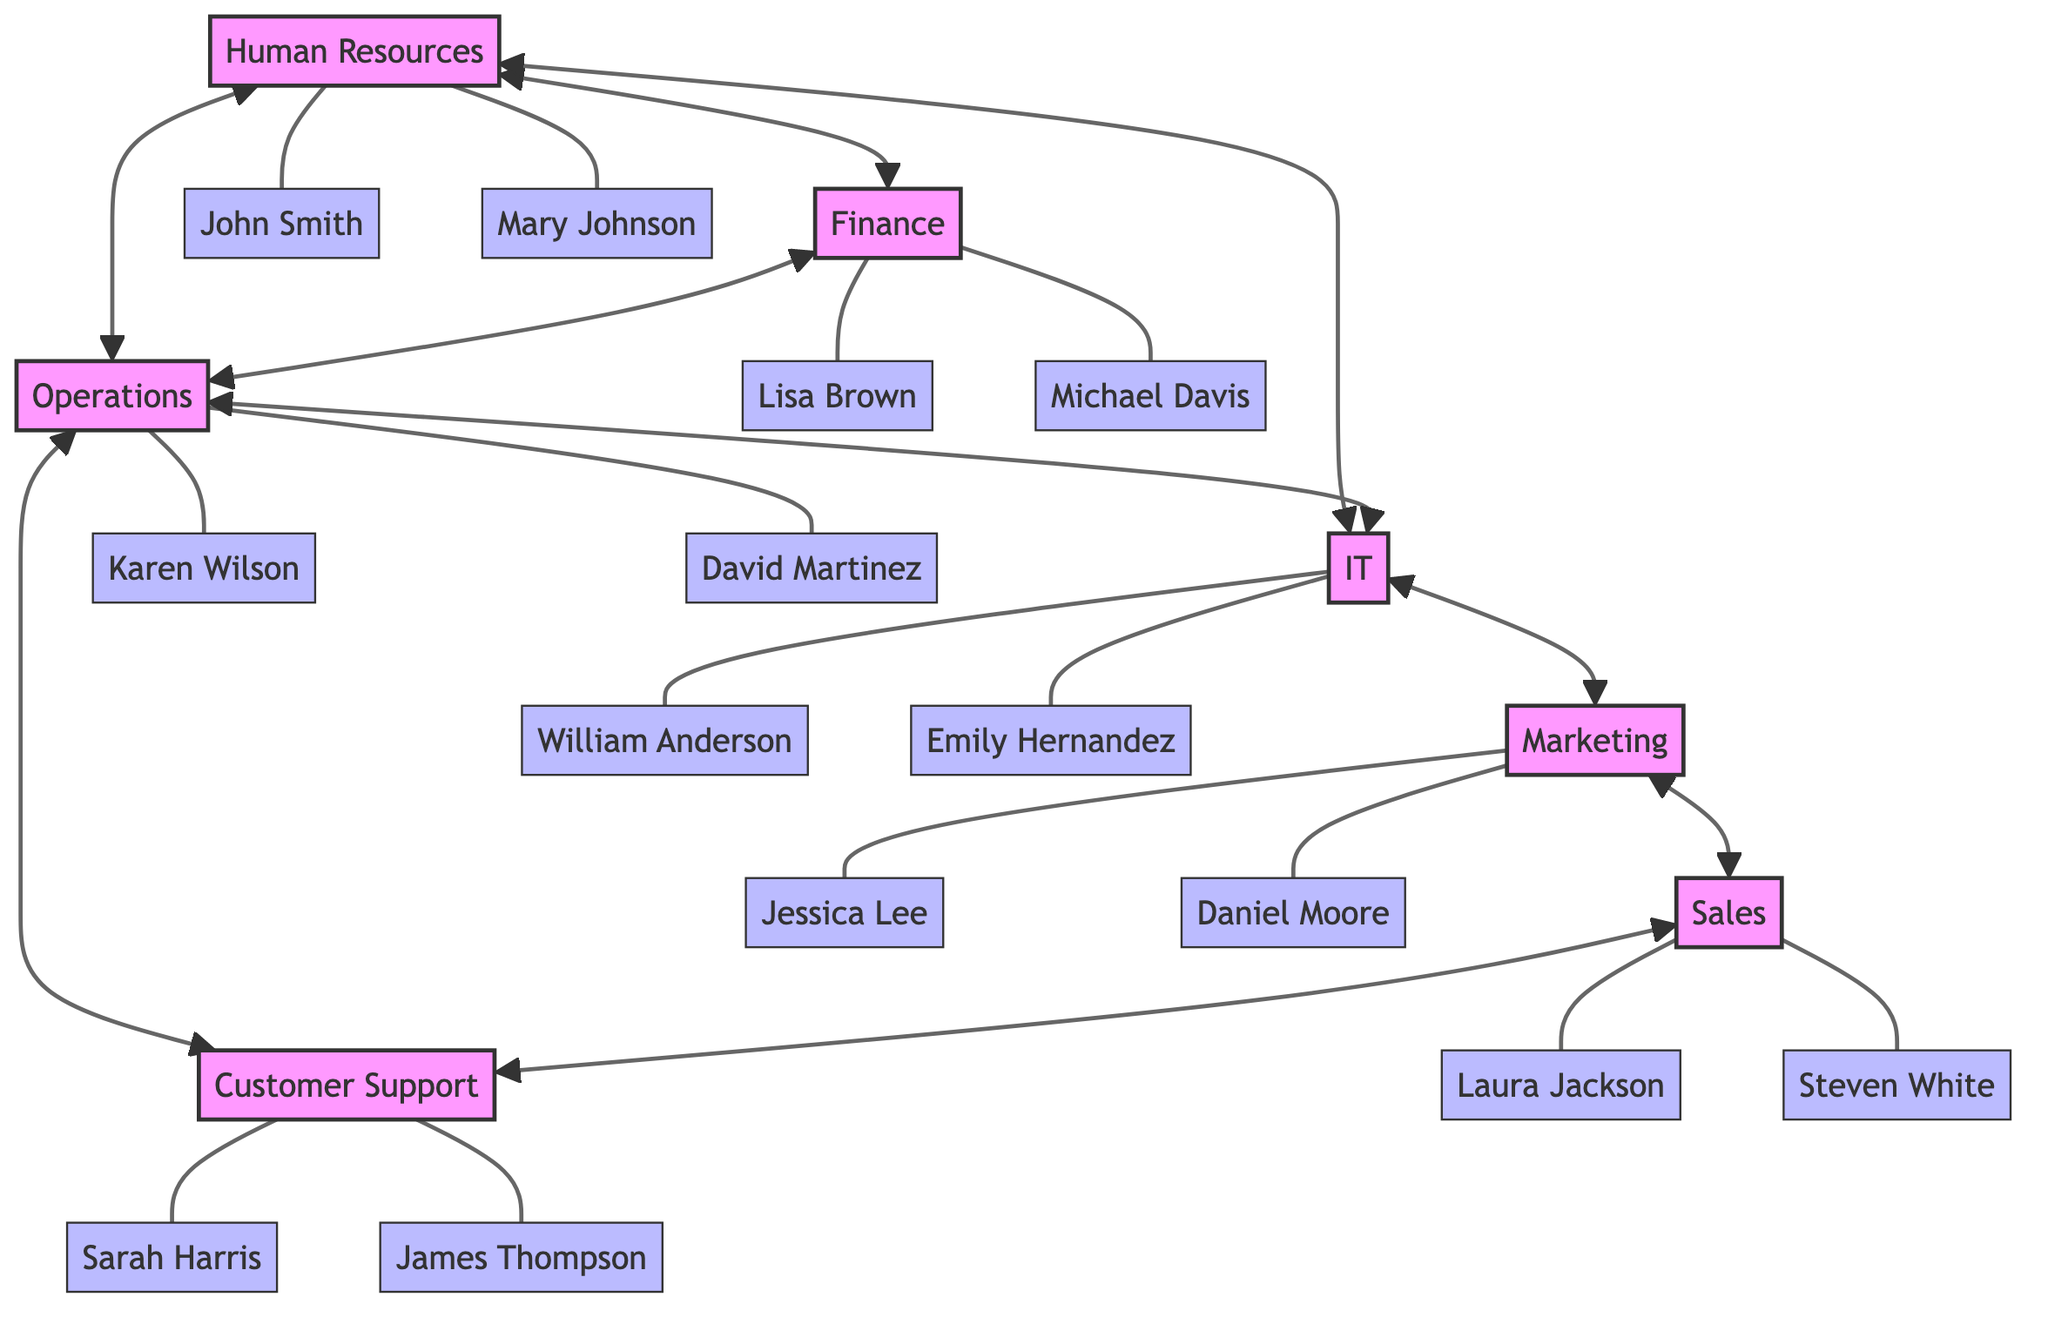What is the primary responsibility of the IT department? The IT department is responsible for Technical Support, Network Management, and Software Development as indicated in the responsibilities listed within the department.
Answer: Technical Support, Network Management, Software Development How many departments are connected to the Human Resources department? The diagram shows that the Human Resources department is connected to three other departments: Finance, IT, and Operations. Therefore, the total is three.
Answer: 3 Which department is responsible for Customer Service? The Customer Support department is responsible for Customer Service, according to the responsibilities specified in the diagram.
Answer: Customer Support What are the names of the contacts in the Sales department? The diagram lists Laura Jackson and Steven White as the contacts for the Sales department, as shown under the contacts section for that department.
Answer: Laura Jackson, Steven White How many contacts are listed for the Finance department? The Finance department has two contacts listed: Lisa Brown and Michael Davis. Counting them gives a total of two contacts.
Answer: 2 Which two departments are directly connected to the Marketing department? The Marketing department is directly connected to the Sales and IT departments, as indicated in the connections specified in the diagram.
Answer: Sales, IT How many total departments are represented in the diagram? The diagram shows a total of seven departments: Human Resources, Finance, Operations, IT, Marketing, Sales, and Customer Support. Adding these up gives seven departments.
Answer: 7 Which department connects Human Resources and Customer Support? The Operations department connects Human Resources and Customer Support indirectly; Human Resources connects to Operations, which in turn connects to Customer Support.
Answer: Operations How many responsibilities does the Operations department have? The Operations department has three responsibilities listed: Production, Quality Control, and Supply Chain Management. Therefore, the total number of responsibilities is three.
Answer: 3 